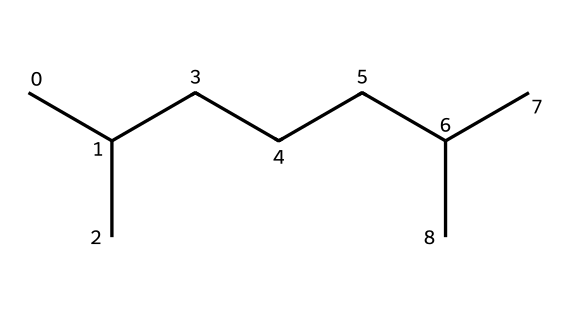What is the molecular formula represented by this SMILES? The SMILES representation indicates a hydrocarbon chain with carbon and hydrogen atoms. Counting the carbon atoms, we find a total of 12 carbon atoms (C), and by deducing the hydrogen atoms from the general alkane formula (C_nH_{2n+2}), we find there are 26 hydrogen atoms (H). Therefore, the molecular formula is C12H26.
Answer: C12H26 How many carbon atoms are in this structure? By analyzing the SMILES notation, we can identify each carbon atom present in the string. In this case, there are 12 carbon atoms.
Answer: 12 What type of hydrocarbon is represented in this structure? Since this structure has only single bonds between carbon atoms with no functional groups (like alcohols or acids), it classifies this as an alkane, specifically a linear alkane.
Answer: alkane What is the Degree of Unsaturation (DoU) in this structure? The Degree of Unsaturation can be calculated by the formula (2C + 2 + N - H - X)/2. For this molecule (12 carbon atoms, 0 nitrogens, 26 hydrogens), DoU = (2*12 + 2)/2 = 13. Since there are only single bonds, the DoU is 0 indicating no rings or double bonds.
Answer: 0 What is the overall molecular class of this chemical? Given its structure as a saturated hydrocarbon with only carbon and hydrogen, this chemical belongs to the class of aliphatic hydrocarbons.
Answer: aliphatic hydrocarbon What is the significance of the branching in this alkane for synthetic motor oil? The branching in alkanes, like the one shown, can enhance the viscosity index of the oil, affecting its flow properties at different temperatures and contributing to improved lubrication in engines.
Answer: enhances viscosity index 